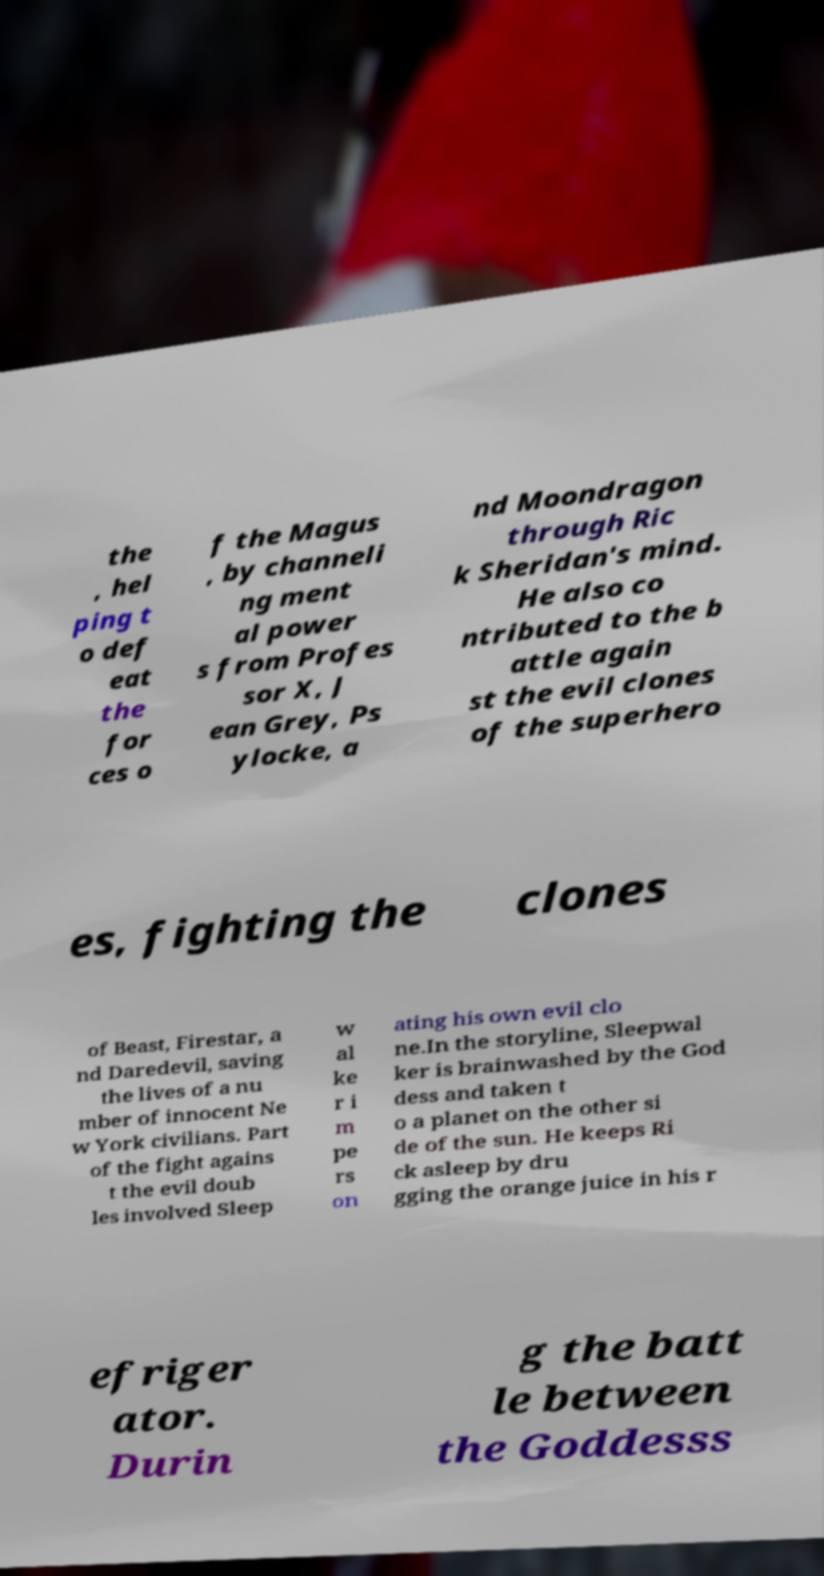For documentation purposes, I need the text within this image transcribed. Could you provide that? the , hel ping t o def eat the for ces o f the Magus , by channeli ng ment al power s from Profes sor X, J ean Grey, Ps ylocke, a nd Moondragon through Ric k Sheridan's mind. He also co ntributed to the b attle again st the evil clones of the superhero es, fighting the clones of Beast, Firestar, a nd Daredevil, saving the lives of a nu mber of innocent Ne w York civilians. Part of the fight agains t the evil doub les involved Sleep w al ke r i m pe rs on ating his own evil clo ne.In the storyline, Sleepwal ker is brainwashed by the God dess and taken t o a planet on the other si de of the sun. He keeps Ri ck asleep by dru gging the orange juice in his r efriger ator. Durin g the batt le between the Goddesss 